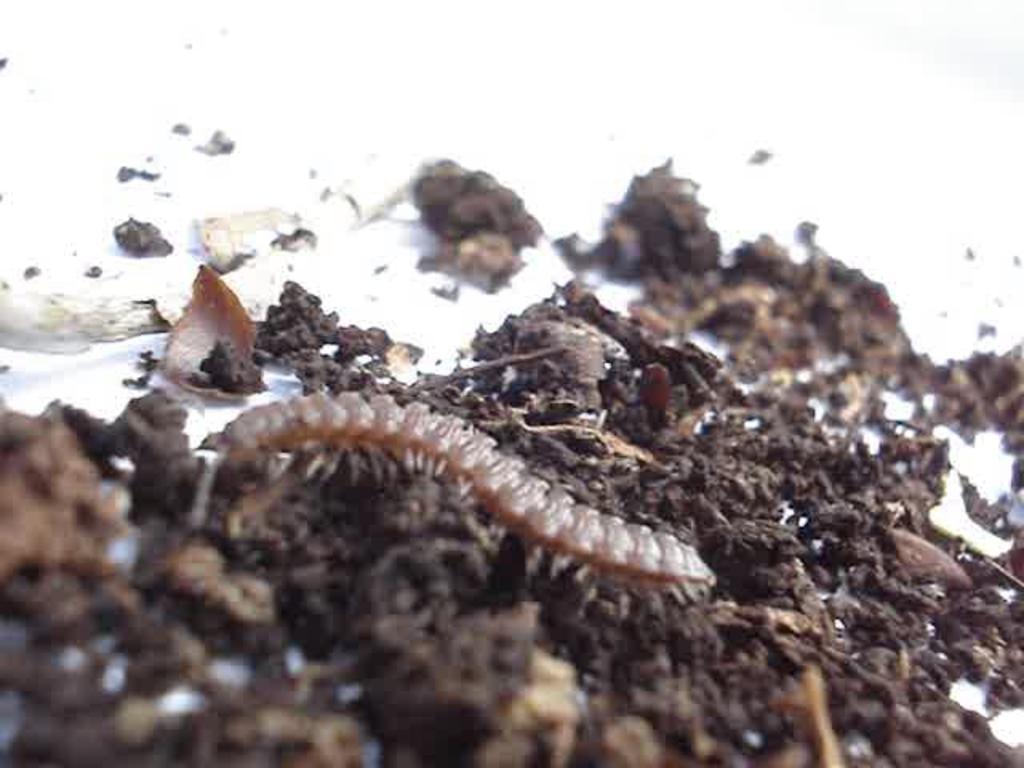Describe this image in one or two sentences. In this image I can see an insect which is in brown color. It is on the mud. The mud is on the white color surface. 